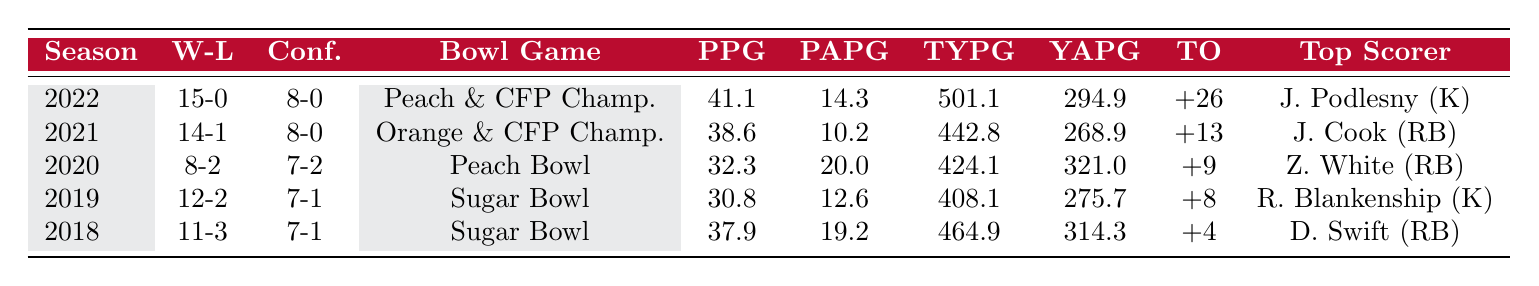What is the win-loss record for the 2022 season? The table shows that the win-loss record for the 2022 season is listed in the "W-L" column. The record is 15-0.
Answer: 15-0 What was the points per game for the team in 2020? The "PPG" column indicates the points per game for each season. For the year 2020, the value is 32.3.
Answer: 32.3 Which season had the highest points allowed per game? To find the season with the highest points allowed per game, examine the "PAPG" column and locate the maximum value. The highest value is 20.0, which is for the 2020 season.
Answer: 2020 How many total yards per game did the team average in 2019? The "TYPG" column shows the total yards per game for each season. In 2019, the average was 408.1 yards.
Answer: 408.1 Which season had the best turnover margin? The "TO" column outlines the turnover margins for the seasons. The best turnover margin is +26 for the 2022 season.
Answer: 2022 What is the average points per game for the last five seasons? To find the average, sum the points per game for all seasons: (41.1 + 38.6 + 32.3 + 30.8 + 37.9) = 180.7. Then divide by 5 to get the average: 180.7 / 5 = 36.14.
Answer: 36.14 Did the team reach a bowl game in every season listed? By looking at the "Bowl Game" column, we can see that each season has a corresponding bowl game listed. Thus, the team did reach a bowl game in every season.
Answer: Yes How does the points per game in 2021 compare to the points allowed per game in the same season? In 2021, the points per game (PPG) was 38.6, while the points allowed per game (PAPG) was 10.2. Since 38.6 is greater than 10.2, the team scored significantly more points than they allowed in 2021.
Answer: Scored more points than allowed What was the total points scored across all five seasons? To find the total points scored, sum up the points per game for each season and multiply by the number of games played. Assuming the number of games played each season mirrors the win-loss record, the total would be: (15*41.1 + 14*38.6 + 8*32.3 + 12*30.8 + 11*37.9) = 621.5 + 540.4 + 258.4 + 369.6 + 416.9 = 2206.6.
Answer: 2206.6 In which year did the team have the highest average of total yards per game? The "TYPG" values are scanned, and the maximum is found in the 2022 season, where the total yards per game were 501.1.
Answer: 2022 What is the connection between the top scorer's position and the team's performance in 2022? The top scorer in 2022 was Jack Podlesny, a kicker, indicating that the team likely scored a significant portion of points through field goals, contributing to their perfect 15-0 season.
Answer: Kicker contributed to success 